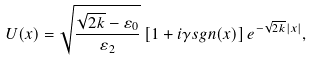Convert formula to latex. <formula><loc_0><loc_0><loc_500><loc_500>U ( x ) = \sqrt { \frac { \sqrt { 2 k } - \varepsilon _ { 0 } } { \varepsilon _ { 2 } } } \left [ 1 + i \gamma s g n ( x ) \right ] e ^ { - \sqrt { 2 k } | x | } ,</formula> 